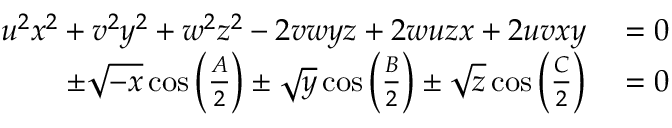Convert formula to latex. <formula><loc_0><loc_0><loc_500><loc_500>\begin{array} { r l } { u ^ { 2 } x ^ { 2 } + v ^ { 2 } y ^ { 2 } + w ^ { 2 } z ^ { 2 } - 2 v w y z + 2 w u z x + 2 u v x y } & = 0 } \\ { \pm { \sqrt { - x } } \cos \left ( { \frac { A } { 2 } } \right ) \pm { \sqrt { y } } \cos \left ( { \frac { B } { 2 } } \right ) \pm { \sqrt { z } } \cos \left ( { \frac { C } { 2 } } \right ) } & = 0 } \end{array}</formula> 